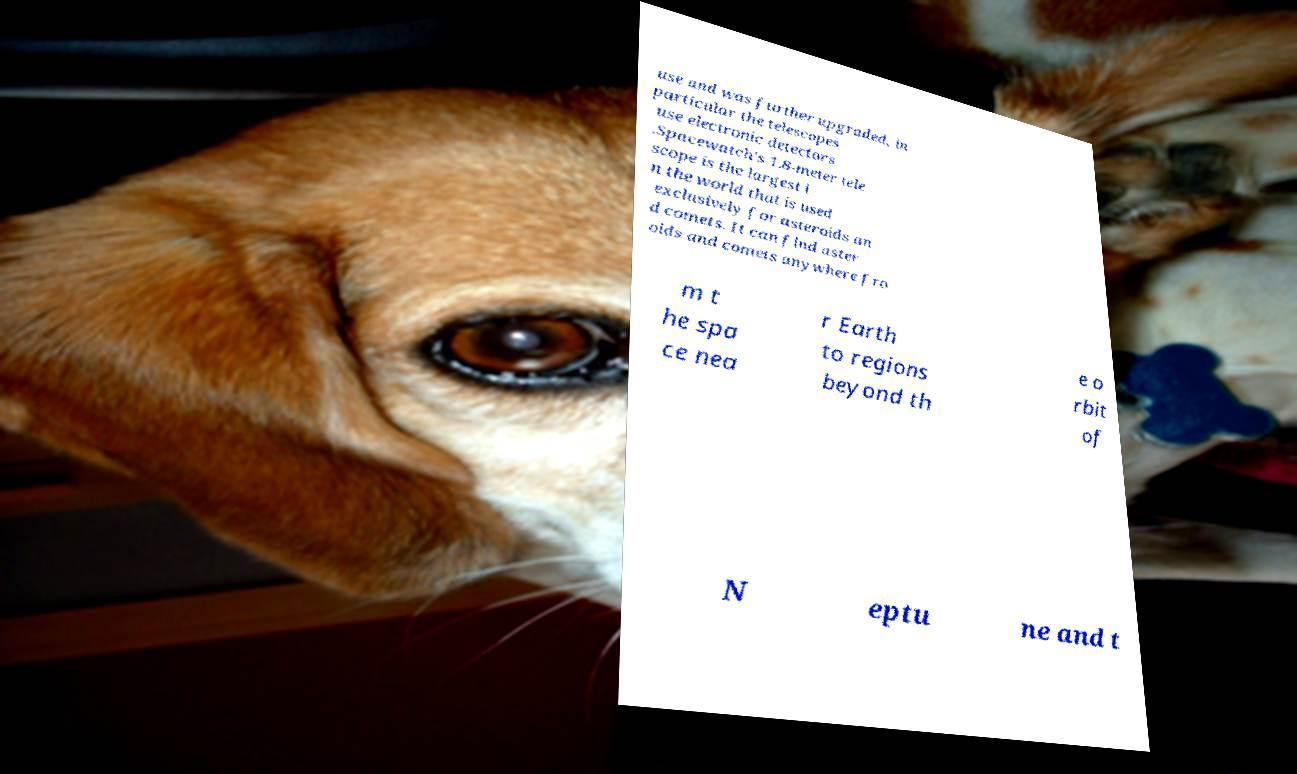For documentation purposes, I need the text within this image transcribed. Could you provide that? use and was further upgraded, in particular the telescopes use electronic detectors .Spacewatch's 1.8-meter tele scope is the largest i n the world that is used exclusively for asteroids an d comets. It can find aster oids and comets anywhere fro m t he spa ce nea r Earth to regions beyond th e o rbit of N eptu ne and t 